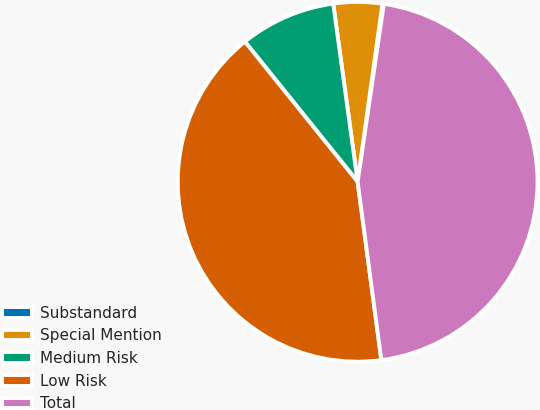Convert chart. <chart><loc_0><loc_0><loc_500><loc_500><pie_chart><fcel>Substandard<fcel>Special Mention<fcel>Medium Risk<fcel>Low Risk<fcel>Total<nl><fcel>0.13%<fcel>4.37%<fcel>8.61%<fcel>41.32%<fcel>45.56%<nl></chart> 